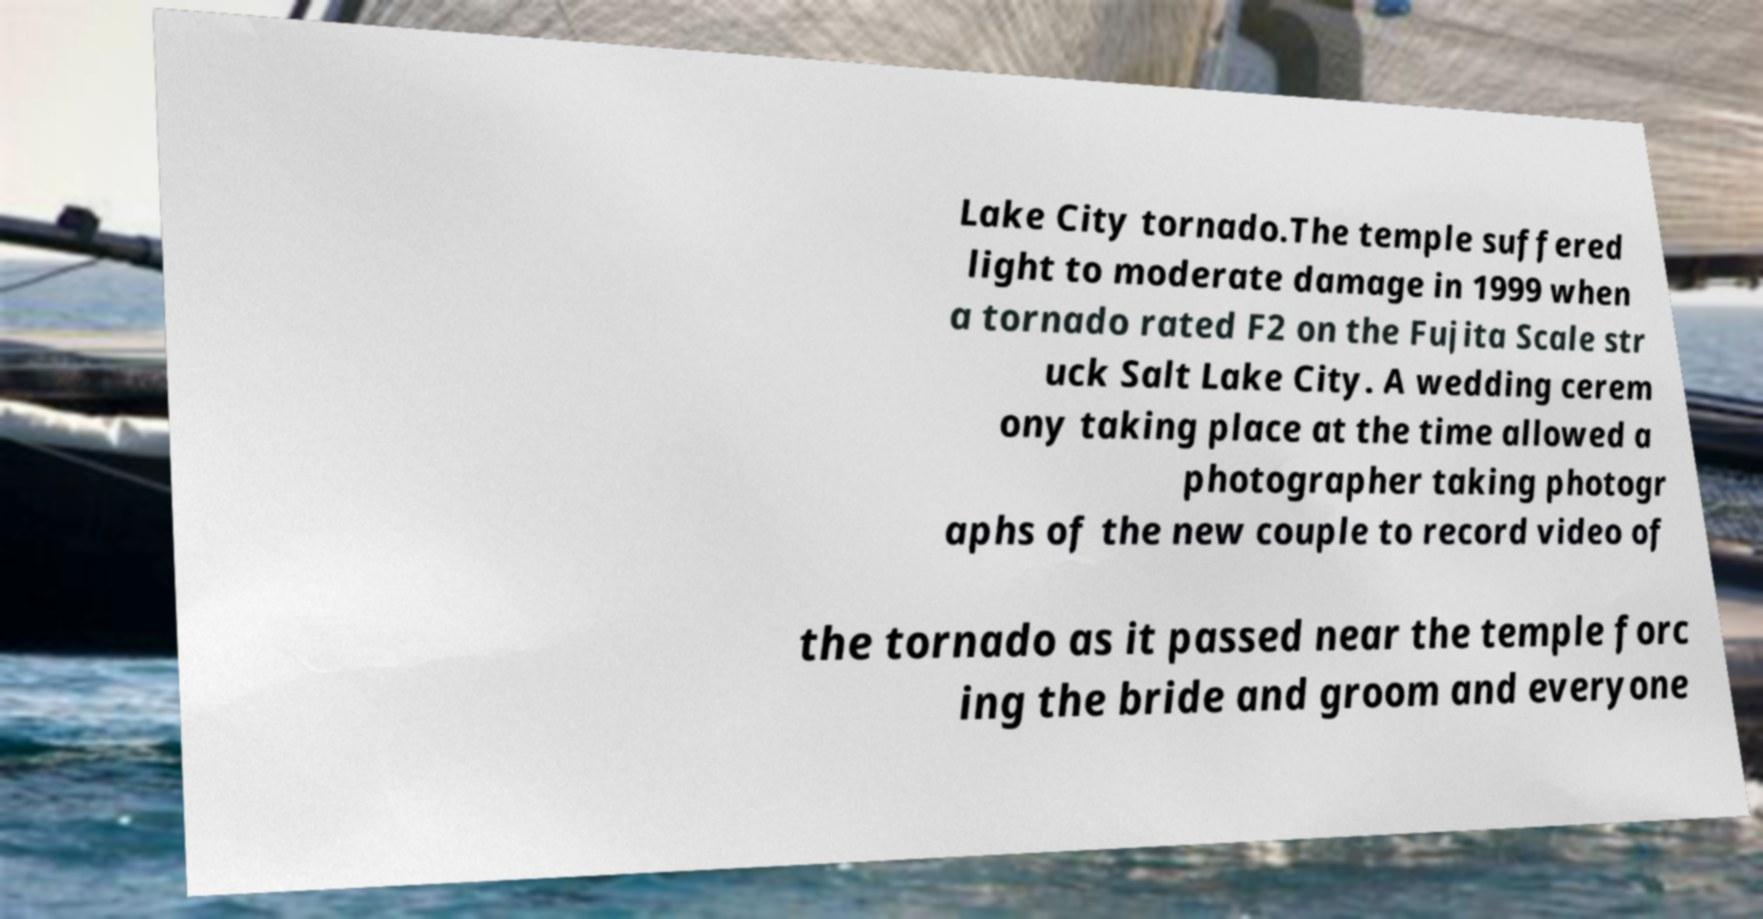Please read and relay the text visible in this image. What does it say? Lake City tornado.The temple suffered light to moderate damage in 1999 when a tornado rated F2 on the Fujita Scale str uck Salt Lake City. A wedding cerem ony taking place at the time allowed a photographer taking photogr aphs of the new couple to record video of the tornado as it passed near the temple forc ing the bride and groom and everyone 